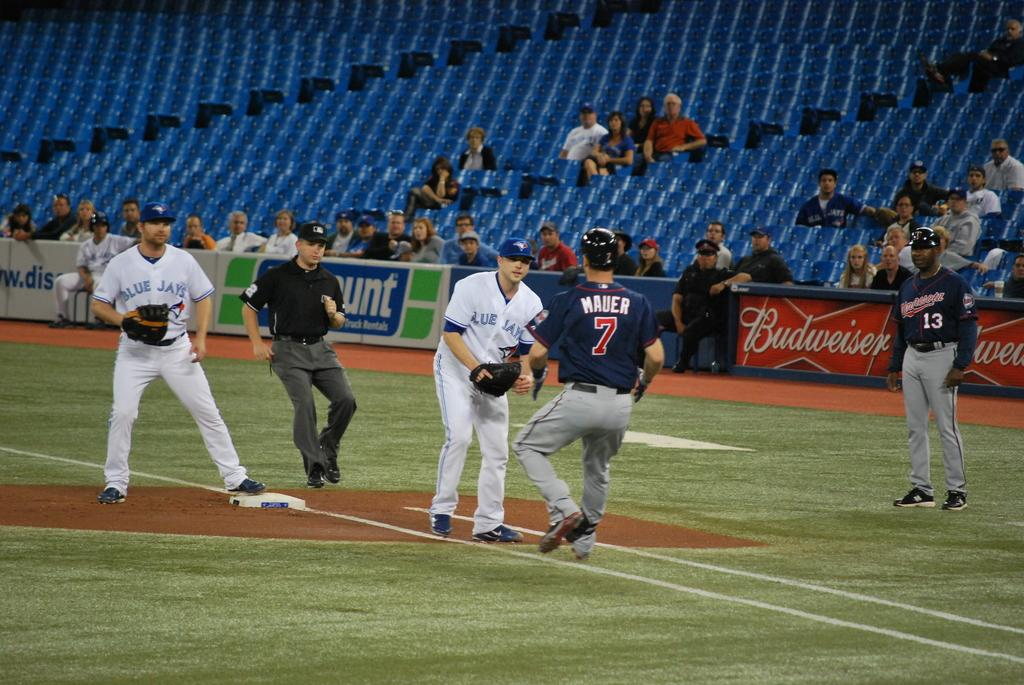Provide a one-sentence caption for the provided image. The Blue Jays try to get a man out at base during sparsely attened baseball game. 